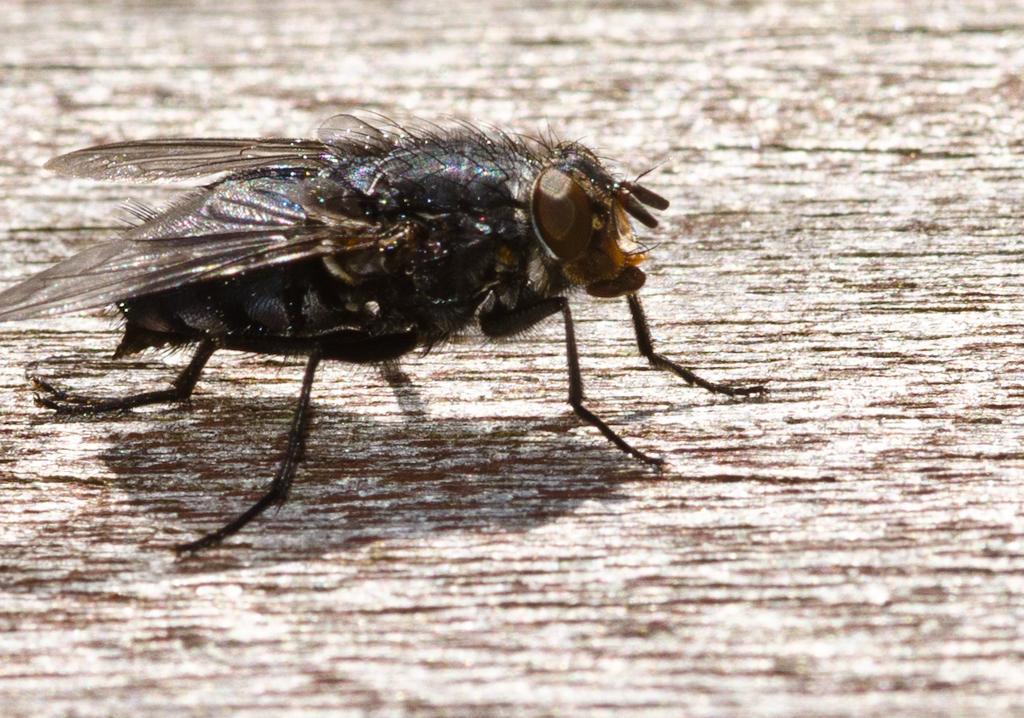How would you summarize this image in a sentence or two? In this image we can see an insect sitting on the wooden surface. 